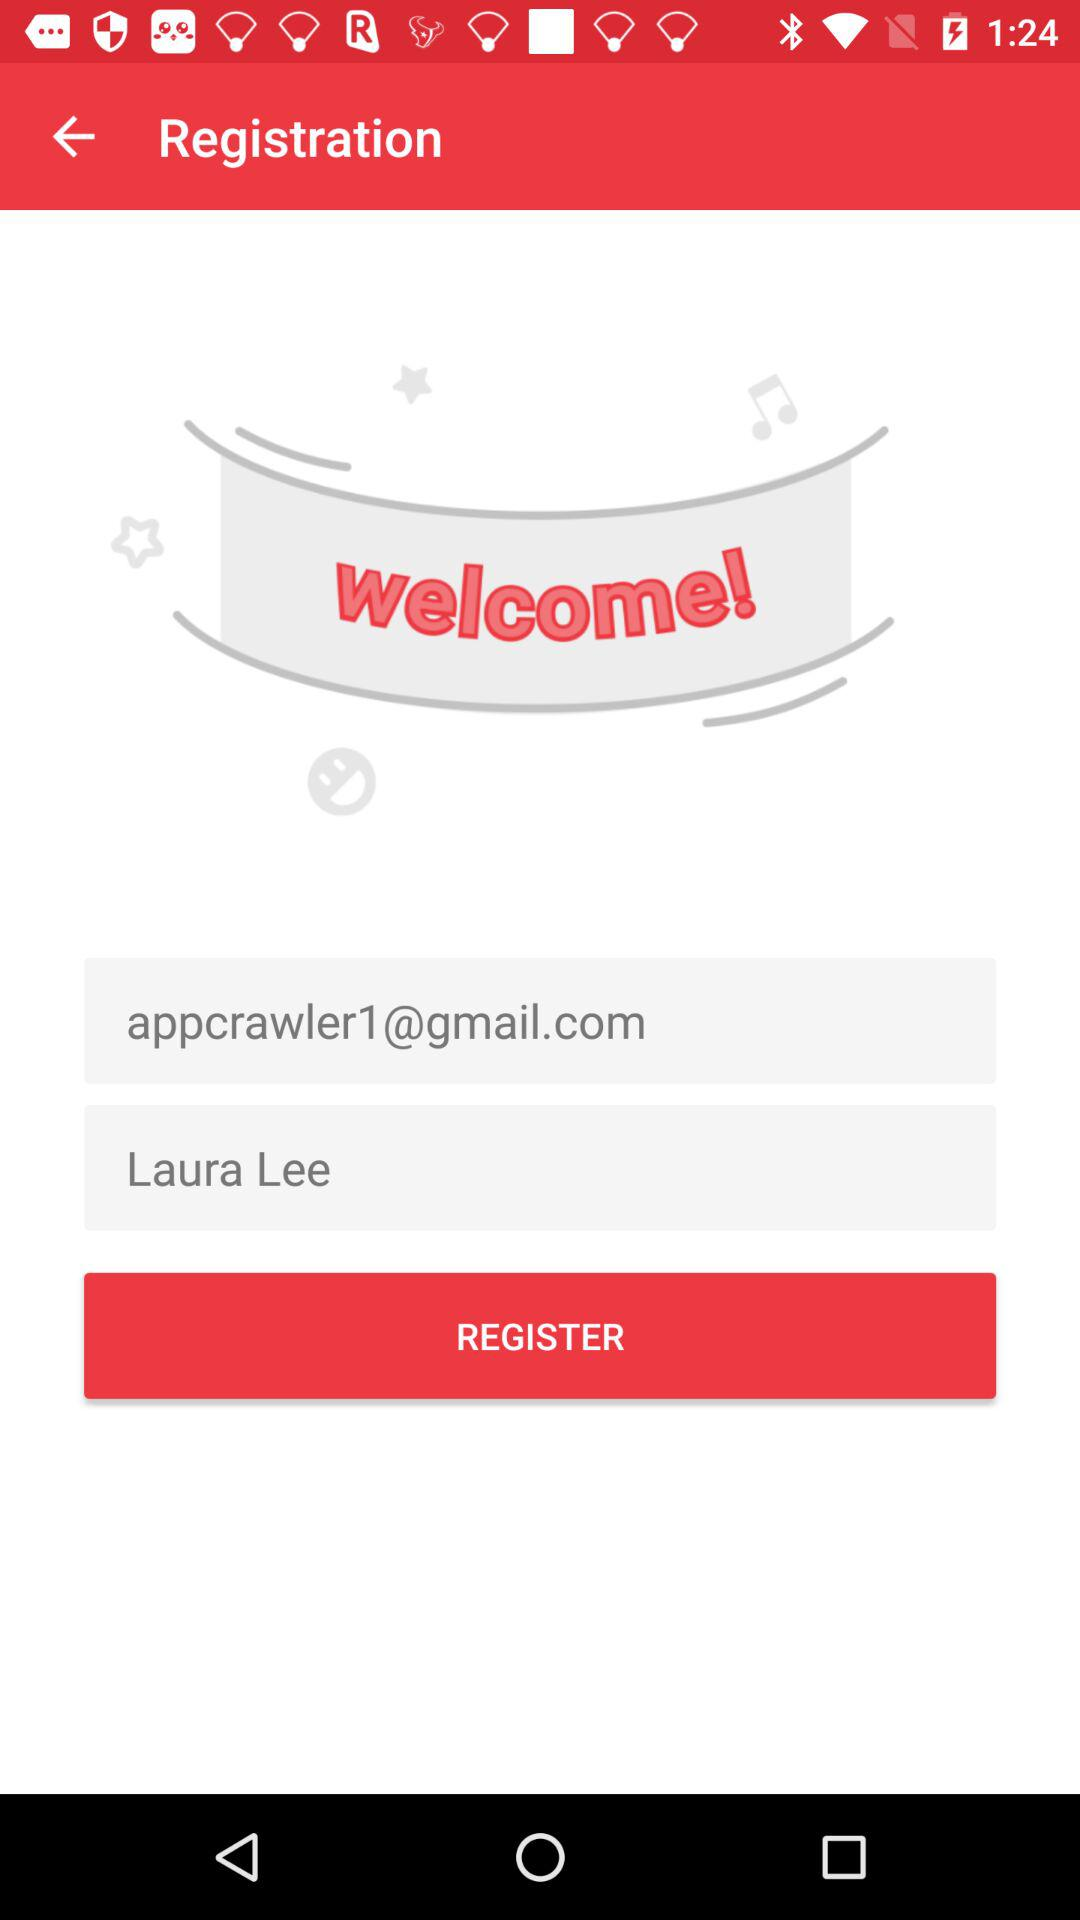When did Laura Lee register?
When the provided information is insufficient, respond with <no answer>. <no answer> 